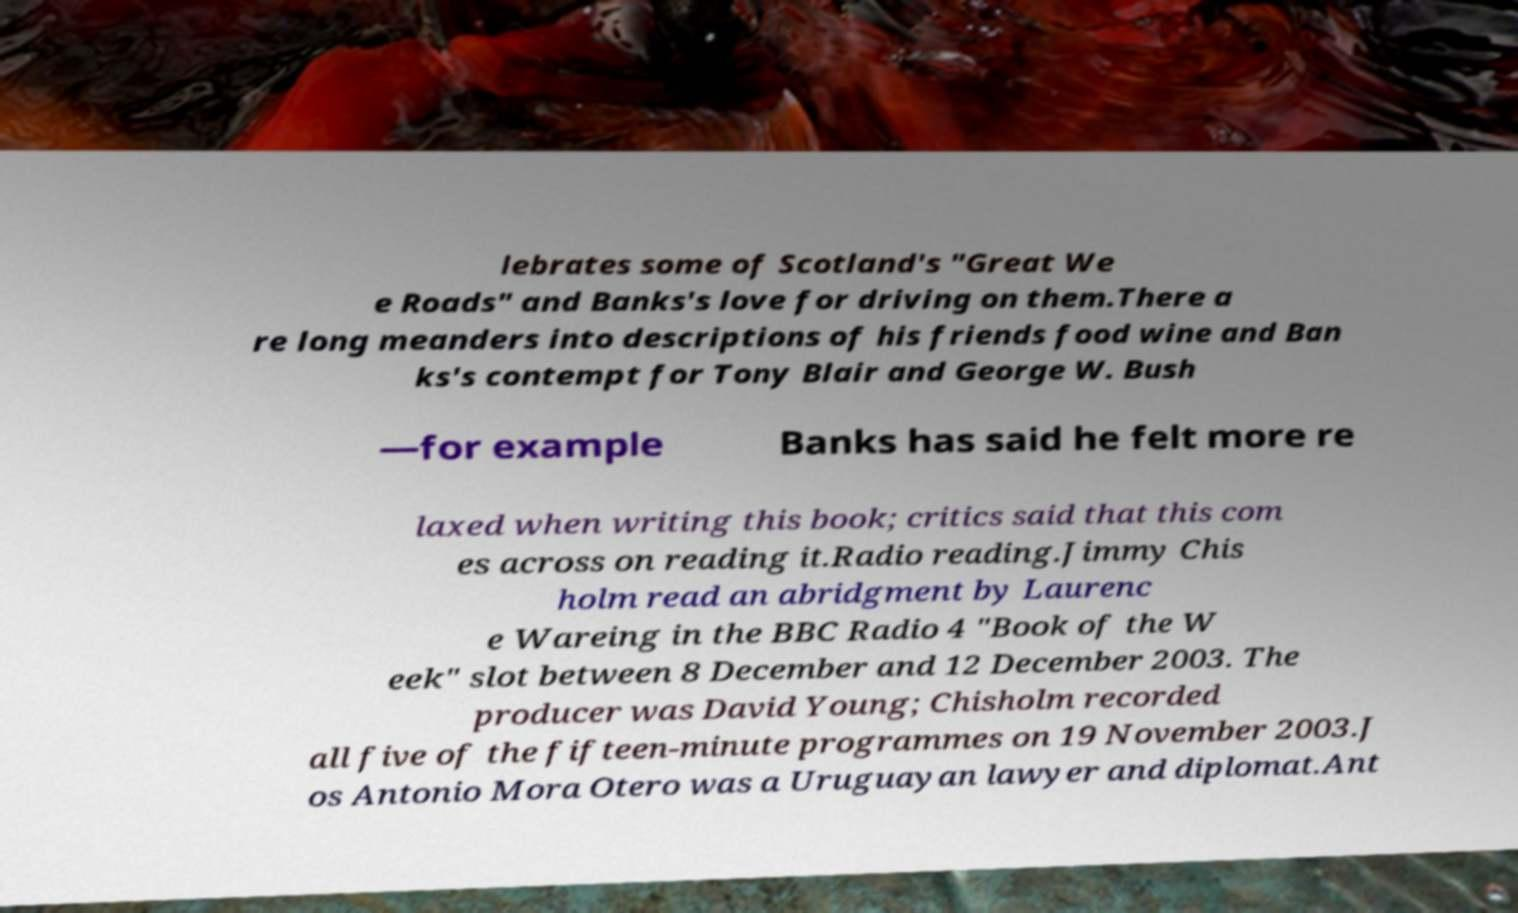Please read and relay the text visible in this image. What does it say? lebrates some of Scotland's "Great We e Roads" and Banks's love for driving on them.There a re long meanders into descriptions of his friends food wine and Ban ks's contempt for Tony Blair and George W. Bush —for example Banks has said he felt more re laxed when writing this book; critics said that this com es across on reading it.Radio reading.Jimmy Chis holm read an abridgment by Laurenc e Wareing in the BBC Radio 4 "Book of the W eek" slot between 8 December and 12 December 2003. The producer was David Young; Chisholm recorded all five of the fifteen-minute programmes on 19 November 2003.J os Antonio Mora Otero was a Uruguayan lawyer and diplomat.Ant 